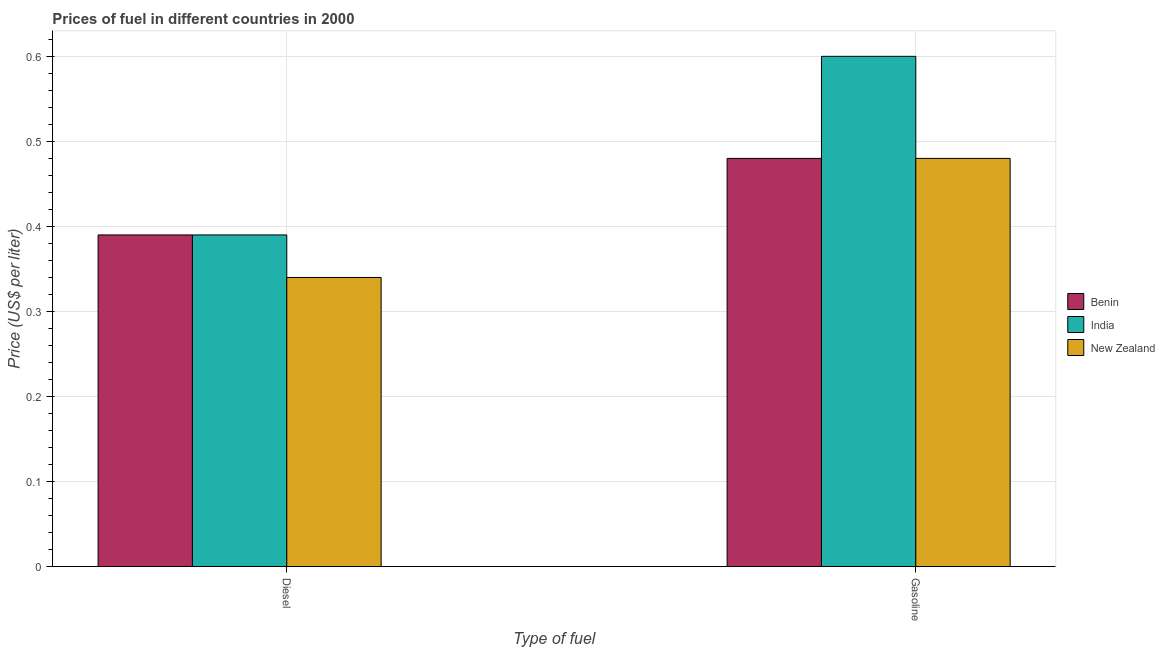How many groups of bars are there?
Offer a terse response. 2. Are the number of bars on each tick of the X-axis equal?
Ensure brevity in your answer.  Yes. What is the label of the 2nd group of bars from the left?
Ensure brevity in your answer.  Gasoline. Across all countries, what is the maximum diesel price?
Your answer should be very brief. 0.39. Across all countries, what is the minimum diesel price?
Offer a terse response. 0.34. In which country was the diesel price maximum?
Make the answer very short. Benin. In which country was the gasoline price minimum?
Ensure brevity in your answer.  Benin. What is the total diesel price in the graph?
Keep it short and to the point. 1.12. What is the difference between the gasoline price in India and the diesel price in Benin?
Ensure brevity in your answer.  0.21. What is the average diesel price per country?
Ensure brevity in your answer.  0.37. What is the difference between the gasoline price and diesel price in Benin?
Offer a terse response. 0.09. In how many countries, is the gasoline price greater than 0.18 US$ per litre?
Provide a short and direct response. 3. What is the ratio of the diesel price in Benin to that in New Zealand?
Provide a short and direct response. 1.15. Is the diesel price in Benin less than that in New Zealand?
Your response must be concise. No. What does the 3rd bar from the left in Gasoline represents?
Your answer should be very brief. New Zealand. What does the 2nd bar from the right in Gasoline represents?
Provide a succinct answer. India. How many bars are there?
Offer a terse response. 6. Are all the bars in the graph horizontal?
Offer a terse response. No. How many countries are there in the graph?
Give a very brief answer. 3. What is the difference between two consecutive major ticks on the Y-axis?
Keep it short and to the point. 0.1. Are the values on the major ticks of Y-axis written in scientific E-notation?
Give a very brief answer. No. Does the graph contain grids?
Provide a succinct answer. Yes. Where does the legend appear in the graph?
Give a very brief answer. Center right. What is the title of the graph?
Offer a very short reply. Prices of fuel in different countries in 2000. What is the label or title of the X-axis?
Ensure brevity in your answer.  Type of fuel. What is the label or title of the Y-axis?
Offer a terse response. Price (US$ per liter). What is the Price (US$ per liter) of Benin in Diesel?
Make the answer very short. 0.39. What is the Price (US$ per liter) in India in Diesel?
Offer a very short reply. 0.39. What is the Price (US$ per liter) in New Zealand in Diesel?
Your answer should be very brief. 0.34. What is the Price (US$ per liter) of Benin in Gasoline?
Provide a short and direct response. 0.48. What is the Price (US$ per liter) in India in Gasoline?
Offer a terse response. 0.6. What is the Price (US$ per liter) in New Zealand in Gasoline?
Your response must be concise. 0.48. Across all Type of fuel, what is the maximum Price (US$ per liter) of Benin?
Keep it short and to the point. 0.48. Across all Type of fuel, what is the maximum Price (US$ per liter) of New Zealand?
Offer a terse response. 0.48. Across all Type of fuel, what is the minimum Price (US$ per liter) of Benin?
Keep it short and to the point. 0.39. Across all Type of fuel, what is the minimum Price (US$ per liter) in India?
Offer a terse response. 0.39. Across all Type of fuel, what is the minimum Price (US$ per liter) in New Zealand?
Give a very brief answer. 0.34. What is the total Price (US$ per liter) of Benin in the graph?
Your response must be concise. 0.87. What is the total Price (US$ per liter) of New Zealand in the graph?
Make the answer very short. 0.82. What is the difference between the Price (US$ per liter) of Benin in Diesel and that in Gasoline?
Keep it short and to the point. -0.09. What is the difference between the Price (US$ per liter) of India in Diesel and that in Gasoline?
Provide a succinct answer. -0.21. What is the difference between the Price (US$ per liter) of New Zealand in Diesel and that in Gasoline?
Offer a terse response. -0.14. What is the difference between the Price (US$ per liter) in Benin in Diesel and the Price (US$ per liter) in India in Gasoline?
Provide a short and direct response. -0.21. What is the difference between the Price (US$ per liter) in Benin in Diesel and the Price (US$ per liter) in New Zealand in Gasoline?
Offer a terse response. -0.09. What is the difference between the Price (US$ per liter) of India in Diesel and the Price (US$ per liter) of New Zealand in Gasoline?
Offer a terse response. -0.09. What is the average Price (US$ per liter) of Benin per Type of fuel?
Your answer should be compact. 0.43. What is the average Price (US$ per liter) in India per Type of fuel?
Offer a terse response. 0.49. What is the average Price (US$ per liter) of New Zealand per Type of fuel?
Your answer should be compact. 0.41. What is the difference between the Price (US$ per liter) of Benin and Price (US$ per liter) of India in Diesel?
Offer a very short reply. 0. What is the difference between the Price (US$ per liter) of Benin and Price (US$ per liter) of New Zealand in Diesel?
Offer a terse response. 0.05. What is the difference between the Price (US$ per liter) of Benin and Price (US$ per liter) of India in Gasoline?
Your answer should be compact. -0.12. What is the difference between the Price (US$ per liter) of India and Price (US$ per liter) of New Zealand in Gasoline?
Make the answer very short. 0.12. What is the ratio of the Price (US$ per liter) in Benin in Diesel to that in Gasoline?
Give a very brief answer. 0.81. What is the ratio of the Price (US$ per liter) of India in Diesel to that in Gasoline?
Offer a very short reply. 0.65. What is the ratio of the Price (US$ per liter) in New Zealand in Diesel to that in Gasoline?
Keep it short and to the point. 0.71. What is the difference between the highest and the second highest Price (US$ per liter) in Benin?
Your response must be concise. 0.09. What is the difference between the highest and the second highest Price (US$ per liter) in India?
Offer a very short reply. 0.21. What is the difference between the highest and the second highest Price (US$ per liter) in New Zealand?
Provide a short and direct response. 0.14. What is the difference between the highest and the lowest Price (US$ per liter) in Benin?
Your answer should be compact. 0.09. What is the difference between the highest and the lowest Price (US$ per liter) of India?
Offer a terse response. 0.21. What is the difference between the highest and the lowest Price (US$ per liter) of New Zealand?
Offer a terse response. 0.14. 